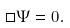<formula> <loc_0><loc_0><loc_500><loc_500>\Box \Psi = 0 .</formula> 